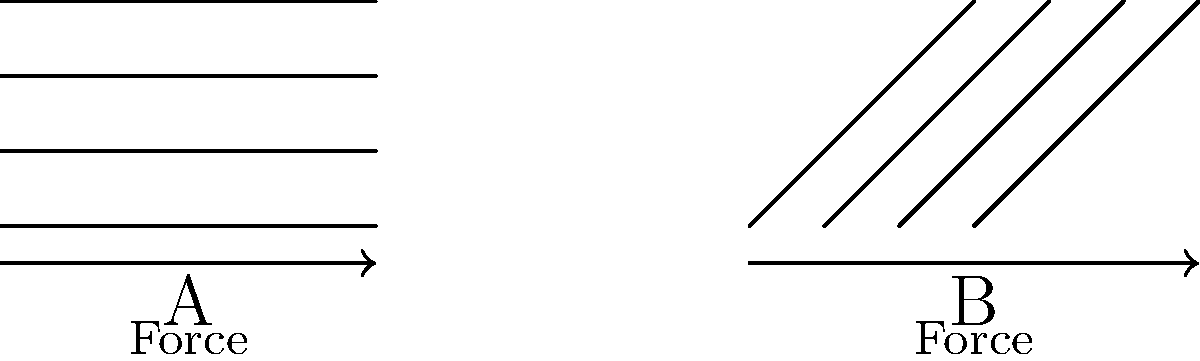Consider the simplified muscle structure diagrams above, where A represents parallel muscle fibers and B represents pennate (angled) muscle fibers. Which arrangement is more likely to produce greater force, and why? Provide a philosophical perspective on how this biomechanical principle might relate to the concept of efficiency in nature. To answer this question, let's approach it step-by-step, integrating biomechanical principles with philosophical considerations:

1. Force production in muscles:
   The force a muscle can produce is directly related to its physiological cross-sectional area (PCSA), which is the total area of all muscle fibers at right angles to their long axes.

2. Parallel fibers (Diagram A):
   - All fibers are aligned in the same direction as the overall muscle.
   - The PCSA is relatively small compared to the muscle's volume.
   - Force is produced directly in line with the muscle's action.

3. Pennate fibers (Diagram B):
   - Fibers are arranged at an angle to the muscle's line of action.
   - This arrangement allows for more fibers to be packed into the same volume, increasing the PCSA.
   - However, not all of the force produced by each fiber contributes to the muscle's overall force due to the angle.

4. Comparison of force production:
   Despite the angular disadvantage, pennate muscles generally produce more force due to their larger PCSA. The increased number of fibers outweighs the loss of force due to the angle.

5. Philosophical perspective:
   This biomechanical principle relates to the concept of efficiency in nature in several ways:
   a) Optimization: Nature often favors designs that maximize output (force) within given constraints (muscle volume).
   b) Trade-offs: The pennate arrangement sacrifices direct force application for increased fiber density, illustrating the balance between competing factors in natural systems.
   c) Form follows function: The structure of pennate muscles is an example of how biological forms are shaped by their functional requirements.

6. Efficiency and teleology:
   The existence of such efficient designs in nature raises questions about purposefulness in biological systems. Are these designs the result of blind evolutionary processes, or do they suggest some form of inherent directionality in nature?

7. Epistemological considerations:
   Our understanding of muscle mechanics demonstrates how empirical observation and mathematical modeling can lead to insights about the natural world, bridging the gap between scientific knowledge and philosophical inquiry.
Answer: Pennate fibers (B) produce greater force due to larger physiological cross-sectional area, exemplifying nature's efficiency through optimized design. 